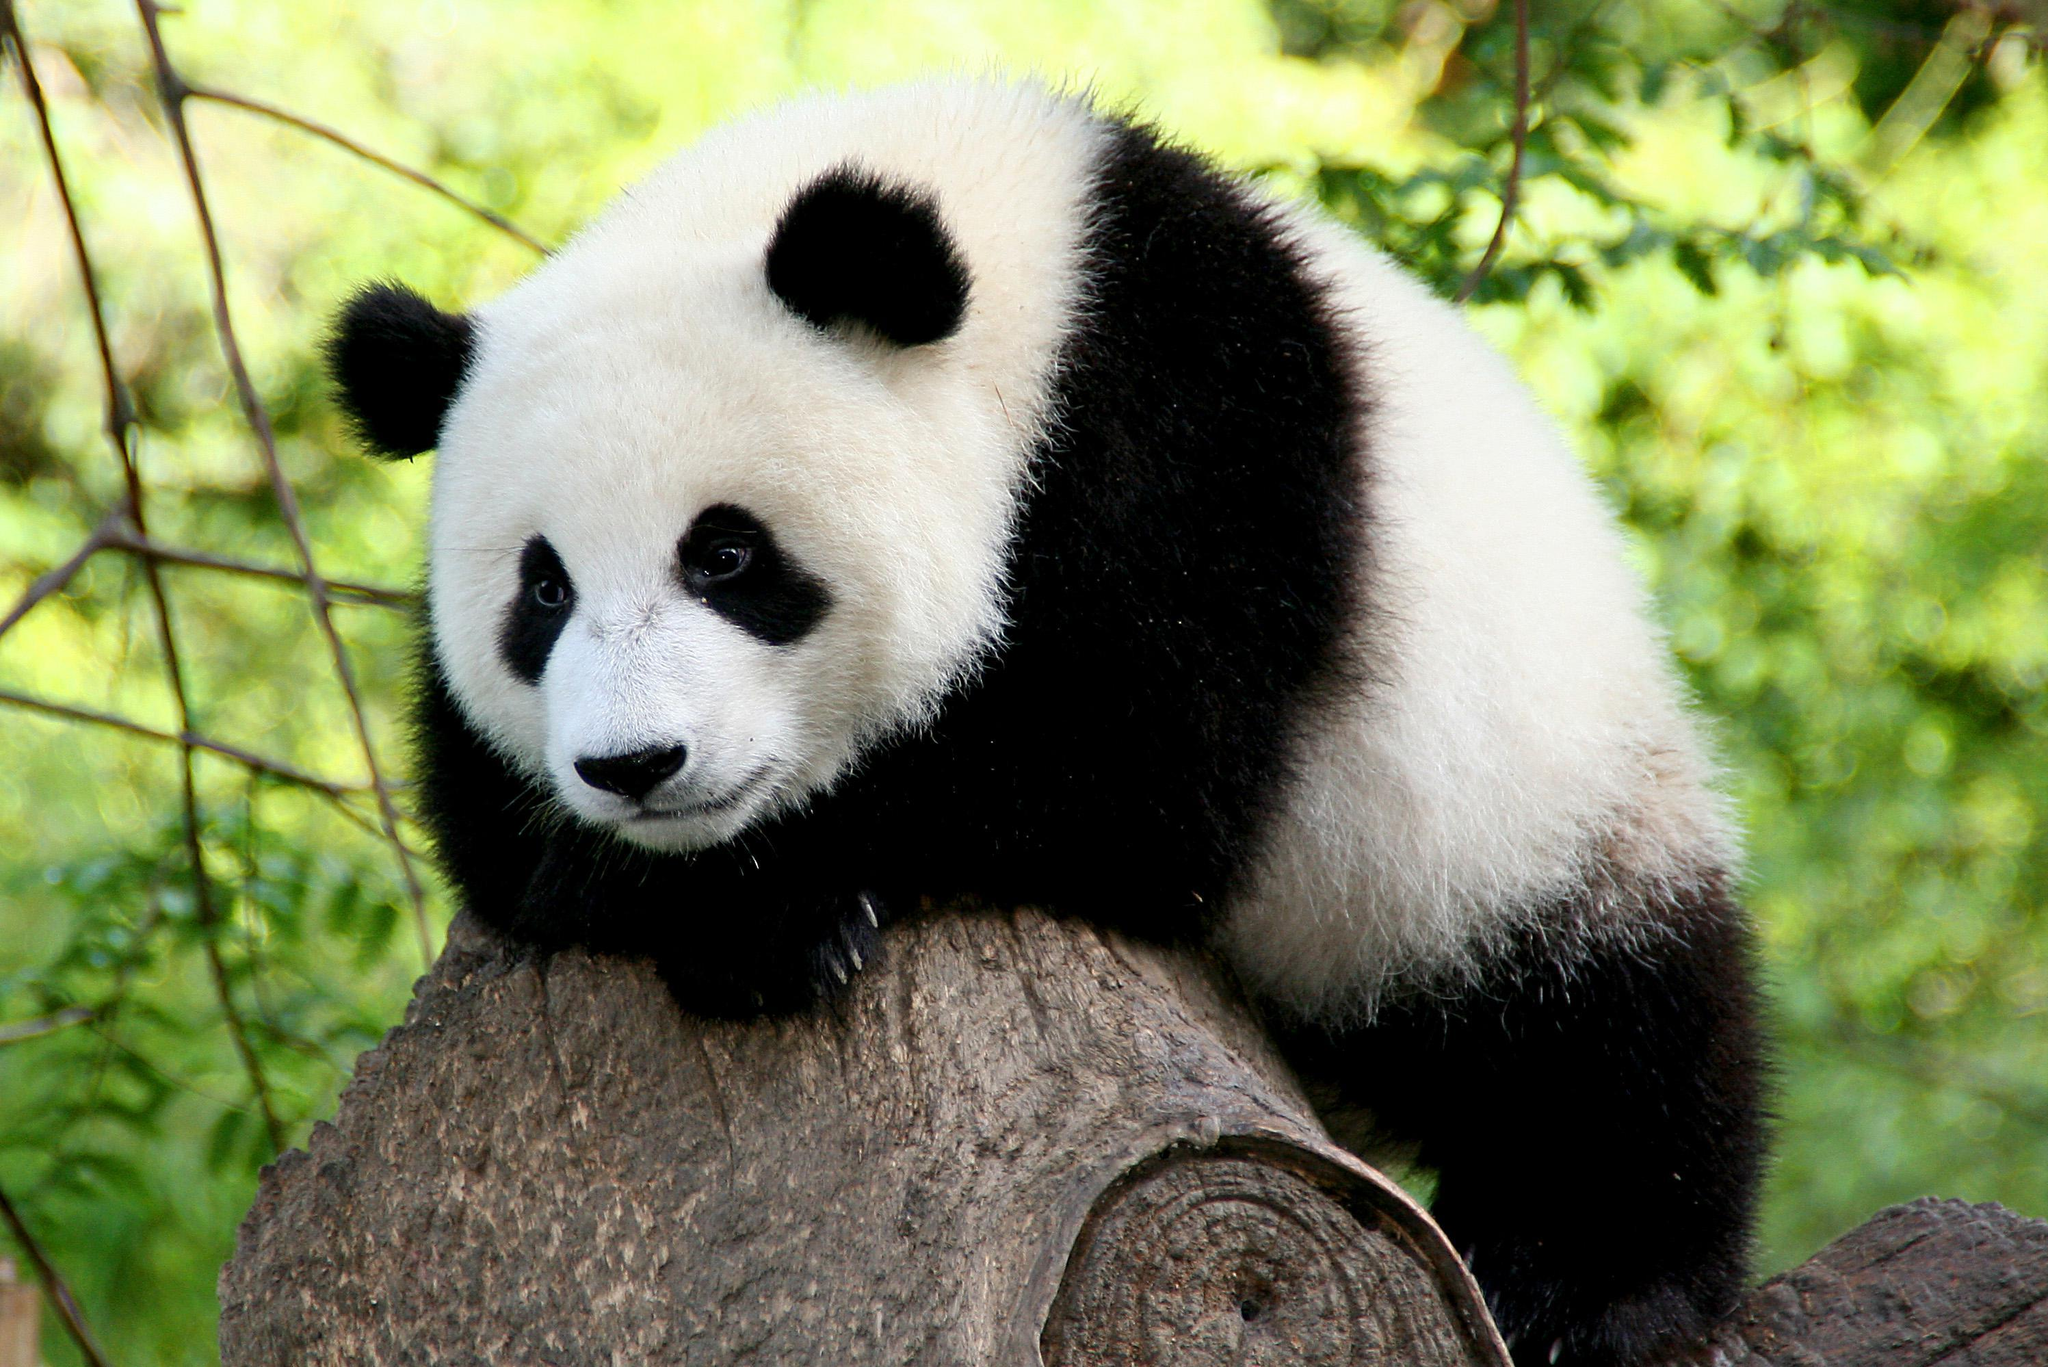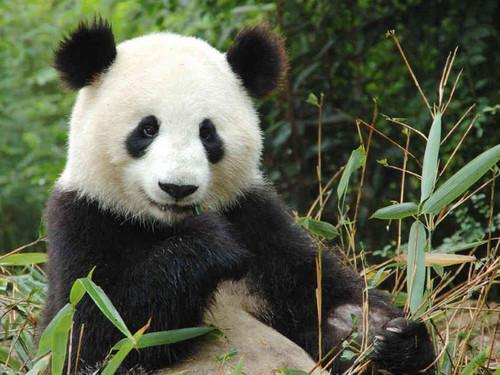The first image is the image on the left, the second image is the image on the right. Considering the images on both sides, is "An image features a panda holding something to its mouth and chewing it." valid? Answer yes or no. Yes. 